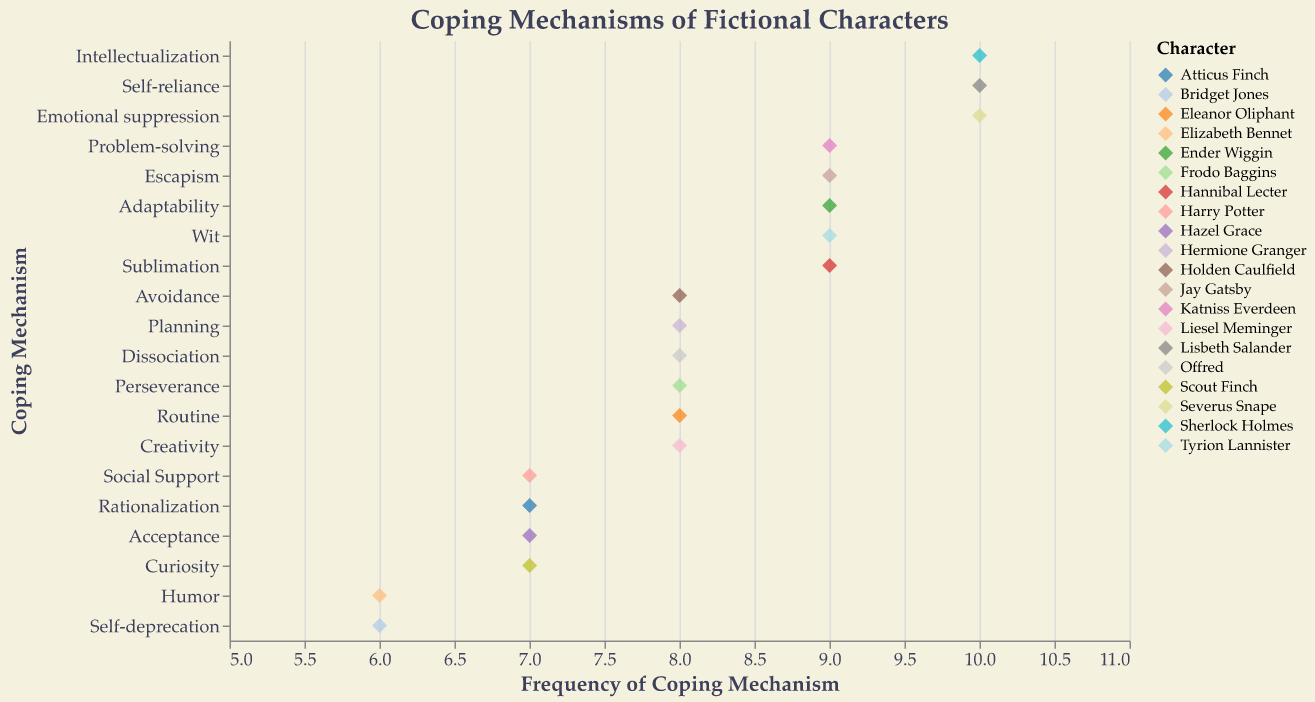What is the title of the strip plot? The title is located at the top center of the strip plot and provides a summary of what the figure is about.
Answer: Coping Mechanisms of Fictional Characters Which character uses the coping mechanism of 'Humor' and what is its frequency? Locate the coping mechanism 'Humor' along the y-axis, then identify the character associated with it and note the frequency on the x-axis.
Answer: Elizabeth Bennet, 6 How many characters have a coping mechanism frequency of 10? Identify all data points with a frequency of 10 along the x-axis and count the corresponding characters.
Answer: 3 Which coping mechanism is used the most by characters in terms of frequency? Consider the 'Frequency' values on the x-axis and look for the coping mechanism with the highest frequencies.
Answer: Intellectualization, Self-reliance, Emotional suppression (all have frequency of 10) Compare the frequency of 'Social Support' and 'Self-deprecation' coping mechanisms. Which one is more frequent? Locate 'Social Support' and 'Self-deprecation' on the y-axis, then compare their frequencies on the x-axis to see which is higher.
Answer: Social Support (7) is more frequent than Self-deprecation (6) What is the average frequency of 'Problem-solving' and 'Dissociation'? Locate 'Problem-solving' and 'Dissociation' on the y-axis, sum their frequencies, and divide by 2.
Answer: (9 + 8) / 2 = 8.5 What is the total frequency of the coping mechanisms used by 'Atticus Finch' and 'Scout Finch'? Identify the coping mechanisms used by Atticus Finch and Scout Finch, sum their frequencies displayed on the x-axis.
Answer: 7 (Rationalization) + 7 (Curiosity) = 14 Which character utilizes 'Self-reliance' and what is its frequency? Find 'Self-reliance' on the y-axis, locate the character associated with it, and note their frequency along the x-axis.
Answer: Lisbeth Salander, 10 How many different coping mechanisms are represented in the strip plot? Count the unique coping mechanisms listed along the y-axis.
Answer: 20 What is the range of the frequencies of 'Adaptability' and 'Acceptance'? Identify the minimum and maximum frequencies for 'Adaptability' and 'Acceptance' on the x-axis and calculate the range.
Answer: 9 (Adaptability) - 7 (Acceptance) = 2 